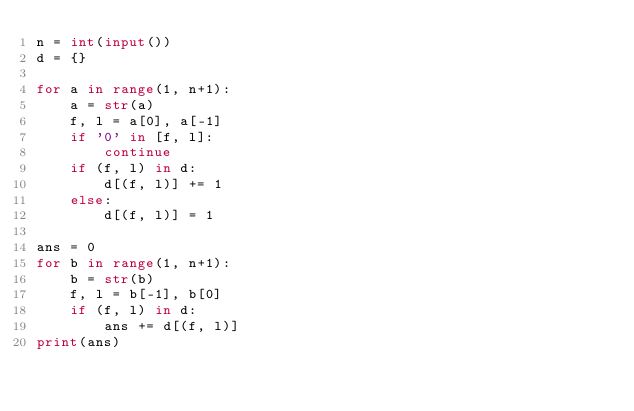Convert code to text. <code><loc_0><loc_0><loc_500><loc_500><_Python_>n = int(input())
d = {}

for a in range(1, n+1):
    a = str(a)
    f, l = a[0], a[-1]
    if '0' in [f, l]:
        continue
    if (f, l) in d:
        d[(f, l)] += 1
    else:
        d[(f, l)] = 1

ans = 0
for b in range(1, n+1):
    b = str(b)
    f, l = b[-1], b[0]
    if (f, l) in d:
        ans += d[(f, l)]
print(ans)</code> 